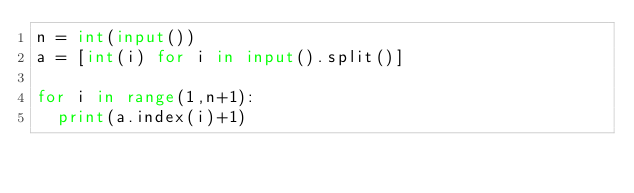Convert code to text. <code><loc_0><loc_0><loc_500><loc_500><_Python_>n = int(input())
a = [int(i) for i in input().split()] 

for i in range(1,n+1):
  print(a.index(i)+1)</code> 